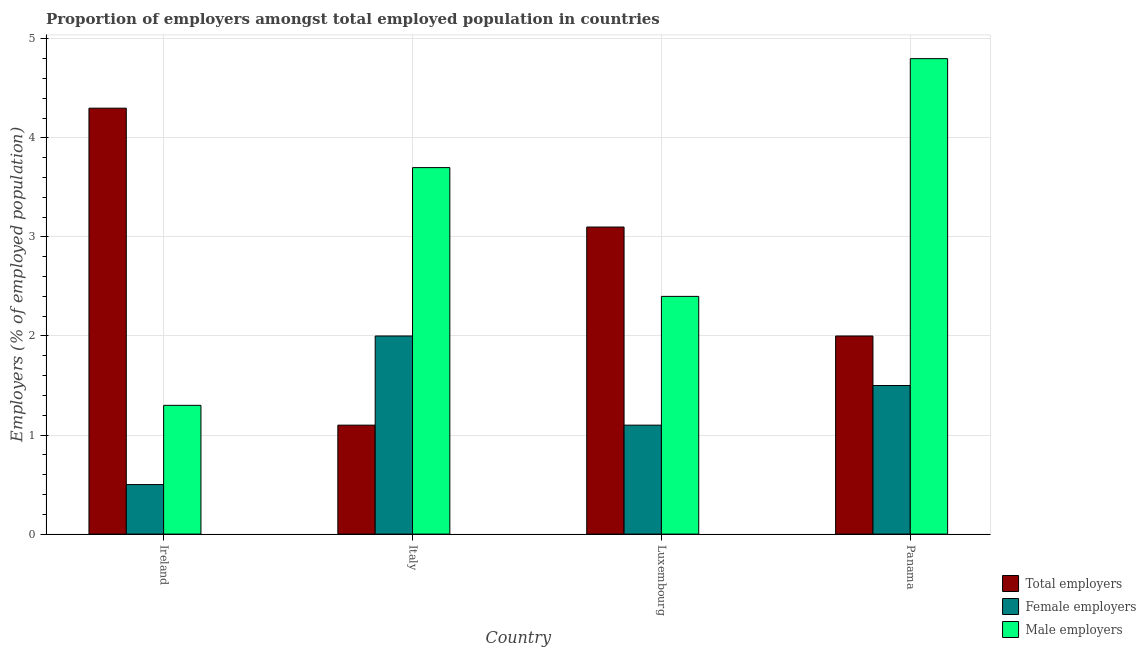Are the number of bars on each tick of the X-axis equal?
Provide a succinct answer. Yes. How many bars are there on the 1st tick from the left?
Offer a very short reply. 3. How many bars are there on the 2nd tick from the right?
Provide a succinct answer. 3. What is the label of the 3rd group of bars from the left?
Provide a short and direct response. Luxembourg. What is the percentage of female employers in Italy?
Offer a very short reply. 2. Across all countries, what is the maximum percentage of total employers?
Your answer should be very brief. 4.3. In which country was the percentage of female employers maximum?
Offer a very short reply. Italy. In which country was the percentage of total employers minimum?
Give a very brief answer. Italy. What is the total percentage of male employers in the graph?
Provide a succinct answer. 12.2. What is the difference between the percentage of male employers in Ireland and that in Panama?
Offer a very short reply. -3.5. What is the difference between the percentage of total employers in Italy and the percentage of male employers in Ireland?
Make the answer very short. -0.2. What is the average percentage of male employers per country?
Ensure brevity in your answer.  3.05. What is the difference between the percentage of total employers and percentage of female employers in Panama?
Offer a very short reply. 0.5. In how many countries, is the percentage of total employers greater than 1.4 %?
Your answer should be compact. 3. What is the ratio of the percentage of female employers in Italy to that in Luxembourg?
Offer a very short reply. 1.82. What is the difference between the highest and the second highest percentage of female employers?
Keep it short and to the point. 0.5. What is the difference between the highest and the lowest percentage of male employers?
Make the answer very short. 3.5. What does the 3rd bar from the left in Italy represents?
Make the answer very short. Male employers. What does the 2nd bar from the right in Panama represents?
Make the answer very short. Female employers. Is it the case that in every country, the sum of the percentage of total employers and percentage of female employers is greater than the percentage of male employers?
Provide a succinct answer. No. What is the difference between two consecutive major ticks on the Y-axis?
Ensure brevity in your answer.  1. Does the graph contain any zero values?
Provide a succinct answer. No. Does the graph contain grids?
Ensure brevity in your answer.  Yes. Where does the legend appear in the graph?
Your answer should be compact. Bottom right. What is the title of the graph?
Provide a short and direct response. Proportion of employers amongst total employed population in countries. What is the label or title of the X-axis?
Ensure brevity in your answer.  Country. What is the label or title of the Y-axis?
Offer a terse response. Employers (% of employed population). What is the Employers (% of employed population) in Total employers in Ireland?
Keep it short and to the point. 4.3. What is the Employers (% of employed population) of Female employers in Ireland?
Provide a succinct answer. 0.5. What is the Employers (% of employed population) in Male employers in Ireland?
Your answer should be very brief. 1.3. What is the Employers (% of employed population) of Total employers in Italy?
Keep it short and to the point. 1.1. What is the Employers (% of employed population) in Female employers in Italy?
Your response must be concise. 2. What is the Employers (% of employed population) of Male employers in Italy?
Offer a very short reply. 3.7. What is the Employers (% of employed population) of Total employers in Luxembourg?
Ensure brevity in your answer.  3.1. What is the Employers (% of employed population) in Female employers in Luxembourg?
Provide a succinct answer. 1.1. What is the Employers (% of employed population) of Male employers in Luxembourg?
Your answer should be compact. 2.4. What is the Employers (% of employed population) of Total employers in Panama?
Offer a very short reply. 2. What is the Employers (% of employed population) in Male employers in Panama?
Provide a succinct answer. 4.8. Across all countries, what is the maximum Employers (% of employed population) of Total employers?
Ensure brevity in your answer.  4.3. Across all countries, what is the maximum Employers (% of employed population) in Male employers?
Provide a succinct answer. 4.8. Across all countries, what is the minimum Employers (% of employed population) in Total employers?
Give a very brief answer. 1.1. Across all countries, what is the minimum Employers (% of employed population) of Female employers?
Give a very brief answer. 0.5. Across all countries, what is the minimum Employers (% of employed population) in Male employers?
Offer a terse response. 1.3. What is the total Employers (% of employed population) of Total employers in the graph?
Your response must be concise. 10.5. What is the difference between the Employers (% of employed population) of Total employers in Ireland and that in Italy?
Provide a short and direct response. 3.2. What is the difference between the Employers (% of employed population) in Male employers in Ireland and that in Italy?
Offer a very short reply. -2.4. What is the difference between the Employers (% of employed population) in Total employers in Ireland and that in Luxembourg?
Offer a very short reply. 1.2. What is the difference between the Employers (% of employed population) of Female employers in Ireland and that in Luxembourg?
Give a very brief answer. -0.6. What is the difference between the Employers (% of employed population) in Male employers in Ireland and that in Panama?
Keep it short and to the point. -3.5. What is the difference between the Employers (% of employed population) in Female employers in Italy and that in Luxembourg?
Keep it short and to the point. 0.9. What is the difference between the Employers (% of employed population) in Total employers in Italy and that in Panama?
Make the answer very short. -0.9. What is the difference between the Employers (% of employed population) in Total employers in Ireland and the Employers (% of employed population) in Female employers in Italy?
Offer a terse response. 2.3. What is the difference between the Employers (% of employed population) in Total employers in Ireland and the Employers (% of employed population) in Male employers in Italy?
Your response must be concise. 0.6. What is the difference between the Employers (% of employed population) of Female employers in Ireland and the Employers (% of employed population) of Male employers in Italy?
Give a very brief answer. -3.2. What is the difference between the Employers (% of employed population) of Female employers in Ireland and the Employers (% of employed population) of Male employers in Luxembourg?
Your response must be concise. -1.9. What is the difference between the Employers (% of employed population) in Total employers in Ireland and the Employers (% of employed population) in Female employers in Panama?
Provide a short and direct response. 2.8. What is the difference between the Employers (% of employed population) in Total employers in Italy and the Employers (% of employed population) in Female employers in Luxembourg?
Your response must be concise. 0. What is the difference between the Employers (% of employed population) of Total employers in Italy and the Employers (% of employed population) of Male employers in Luxembourg?
Offer a very short reply. -1.3. What is the difference between the Employers (% of employed population) in Total employers in Luxembourg and the Employers (% of employed population) in Female employers in Panama?
Keep it short and to the point. 1.6. What is the difference between the Employers (% of employed population) in Total employers in Luxembourg and the Employers (% of employed population) in Male employers in Panama?
Offer a terse response. -1.7. What is the average Employers (% of employed population) of Total employers per country?
Make the answer very short. 2.62. What is the average Employers (% of employed population) in Female employers per country?
Your answer should be compact. 1.27. What is the average Employers (% of employed population) in Male employers per country?
Ensure brevity in your answer.  3.05. What is the difference between the Employers (% of employed population) of Total employers and Employers (% of employed population) of Female employers in Ireland?
Offer a very short reply. 3.8. What is the difference between the Employers (% of employed population) of Total employers and Employers (% of employed population) of Male employers in Ireland?
Keep it short and to the point. 3. What is the difference between the Employers (% of employed population) in Female employers and Employers (% of employed population) in Male employers in Italy?
Your answer should be compact. -1.7. What is the difference between the Employers (% of employed population) in Total employers and Employers (% of employed population) in Female employers in Luxembourg?
Your answer should be compact. 2. What is the difference between the Employers (% of employed population) of Total employers and Employers (% of employed population) of Male employers in Panama?
Your answer should be compact. -2.8. What is the ratio of the Employers (% of employed population) in Total employers in Ireland to that in Italy?
Offer a very short reply. 3.91. What is the ratio of the Employers (% of employed population) in Female employers in Ireland to that in Italy?
Offer a terse response. 0.25. What is the ratio of the Employers (% of employed population) of Male employers in Ireland to that in Italy?
Keep it short and to the point. 0.35. What is the ratio of the Employers (% of employed population) of Total employers in Ireland to that in Luxembourg?
Your answer should be very brief. 1.39. What is the ratio of the Employers (% of employed population) of Female employers in Ireland to that in Luxembourg?
Provide a succinct answer. 0.45. What is the ratio of the Employers (% of employed population) in Male employers in Ireland to that in Luxembourg?
Make the answer very short. 0.54. What is the ratio of the Employers (% of employed population) in Total employers in Ireland to that in Panama?
Your response must be concise. 2.15. What is the ratio of the Employers (% of employed population) of Female employers in Ireland to that in Panama?
Provide a succinct answer. 0.33. What is the ratio of the Employers (% of employed population) of Male employers in Ireland to that in Panama?
Keep it short and to the point. 0.27. What is the ratio of the Employers (% of employed population) in Total employers in Italy to that in Luxembourg?
Your answer should be compact. 0.35. What is the ratio of the Employers (% of employed population) of Female employers in Italy to that in Luxembourg?
Provide a short and direct response. 1.82. What is the ratio of the Employers (% of employed population) in Male employers in Italy to that in Luxembourg?
Offer a terse response. 1.54. What is the ratio of the Employers (% of employed population) of Total employers in Italy to that in Panama?
Give a very brief answer. 0.55. What is the ratio of the Employers (% of employed population) of Female employers in Italy to that in Panama?
Provide a short and direct response. 1.33. What is the ratio of the Employers (% of employed population) of Male employers in Italy to that in Panama?
Ensure brevity in your answer.  0.77. What is the ratio of the Employers (% of employed population) of Total employers in Luxembourg to that in Panama?
Keep it short and to the point. 1.55. What is the ratio of the Employers (% of employed population) of Female employers in Luxembourg to that in Panama?
Provide a succinct answer. 0.73. What is the ratio of the Employers (% of employed population) of Male employers in Luxembourg to that in Panama?
Your answer should be very brief. 0.5. What is the difference between the highest and the second highest Employers (% of employed population) in Total employers?
Provide a succinct answer. 1.2. What is the difference between the highest and the second highest Employers (% of employed population) in Female employers?
Offer a terse response. 0.5. What is the difference between the highest and the lowest Employers (% of employed population) of Total employers?
Offer a very short reply. 3.2. What is the difference between the highest and the lowest Employers (% of employed population) in Female employers?
Ensure brevity in your answer.  1.5. What is the difference between the highest and the lowest Employers (% of employed population) of Male employers?
Provide a short and direct response. 3.5. 